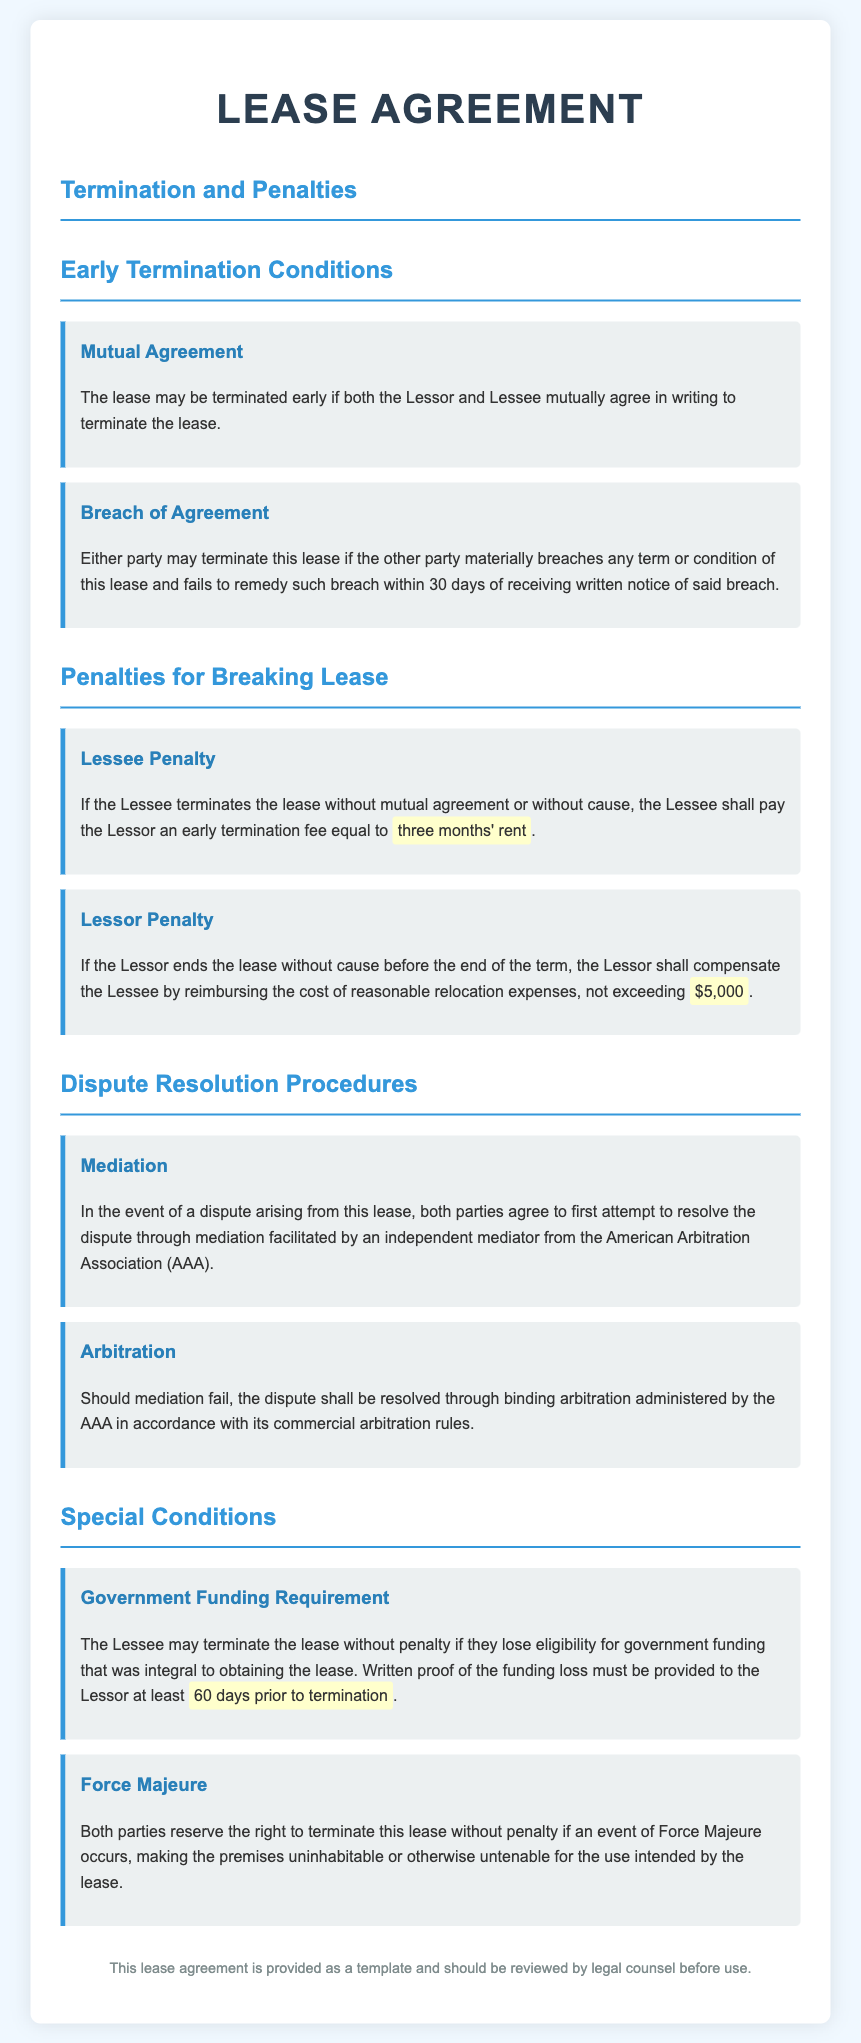What are the conditions for early termination? The conditions for early termination include mutual agreement and breach of agreement.
Answer: mutual agreement, breach of agreement What is the penalty for the Lessee if they terminate the lease without cause? The penalty for the Lessee is an early termination fee equal to three months' rent.
Answer: three months' rent What compensation does the Lessor owe the Lessee if they end the lease early without cause? The Lessor shall compensate the Lessee by reimbursing the cost of reasonable relocation expenses.
Answer: cost of reasonable relocation expenses What is the maximum amount for Lessor compensation? The maximum amount for Lessor compensation is not exceeding $5,000.
Answer: $5,000 What is the first step in the dispute resolution procedures? The first step is mediation facilitated by an independent mediator from the American Arbitration Association.
Answer: mediation How many days’ notice is required for the Lessee to terminate the lease due to loss of government funding? The Lessee must provide written proof at least 60 days prior to termination.
Answer: 60 days What must both parties do if an event of Force Majeure occurs? Both parties reserve the right to terminate the lease without penalty.
Answer: terminate the lease without penalty What is the document's recommendation regarding legal counsel? The document states that it should be reviewed by legal counsel before use.
Answer: reviewed by legal counsel 